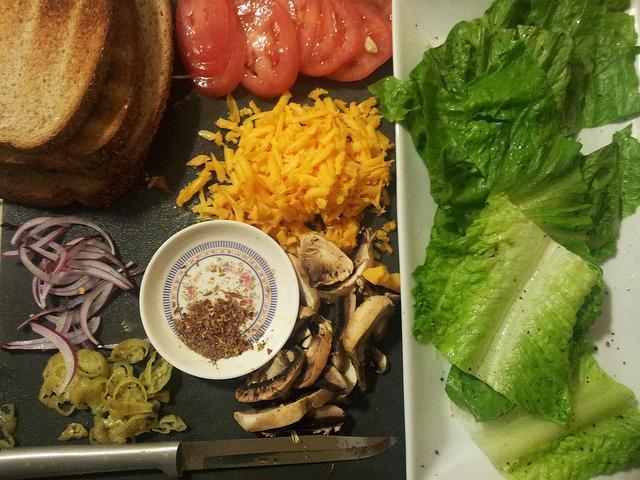How many knives can you see?
Give a very brief answer. 1. How many people in the picture are standing on the tennis court?
Give a very brief answer. 0. 